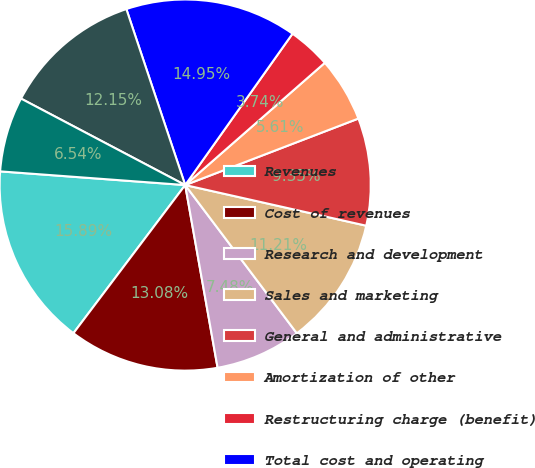<chart> <loc_0><loc_0><loc_500><loc_500><pie_chart><fcel>Revenues<fcel>Cost of revenues<fcel>Research and development<fcel>Sales and marketing<fcel>General and administrative<fcel>Amortization of other<fcel>Restructuring charge (benefit)<fcel>Total cost and operating<fcel>Income from operations<fcel>Interest income<nl><fcel>15.89%<fcel>13.08%<fcel>7.48%<fcel>11.21%<fcel>9.35%<fcel>5.61%<fcel>3.74%<fcel>14.95%<fcel>12.15%<fcel>6.54%<nl></chart> 